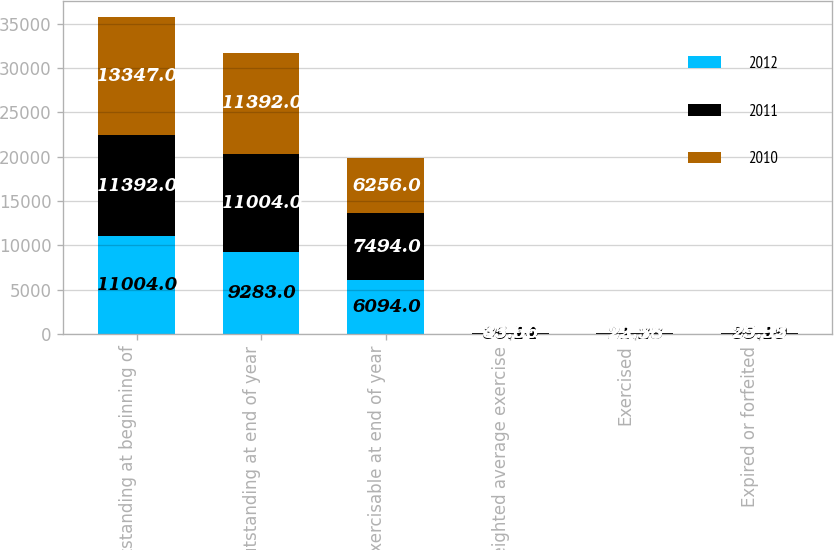Convert chart. <chart><loc_0><loc_0><loc_500><loc_500><stacked_bar_chart><ecel><fcel>Outstanding at beginning of<fcel>Outstanding at end of year<fcel>Exercisable at end of year<fcel>Weighted average exercise<fcel>Exercised<fcel>Expired or forfeited<nl><fcel>2012<fcel>11004<fcel>9283<fcel>6094<fcel>36.14<fcel>21.23<fcel>35.19<nl><fcel>2011<fcel>11392<fcel>11004<fcel>7494<fcel>45.66<fcel>23.55<fcel>29.35<nl><fcel>2010<fcel>13347<fcel>11392<fcel>6256<fcel>33.96<fcel>22.78<fcel>25.92<nl></chart> 